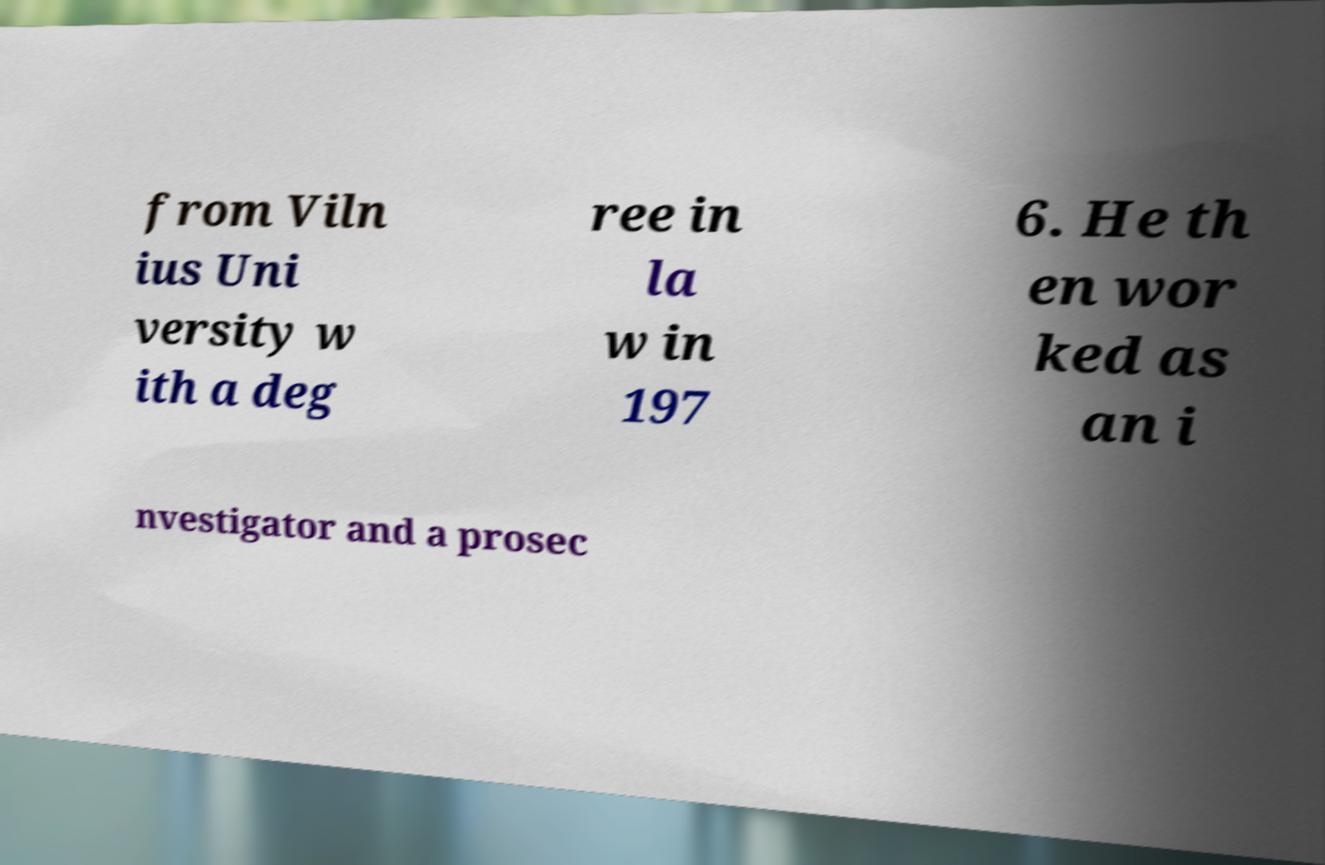Could you extract and type out the text from this image? from Viln ius Uni versity w ith a deg ree in la w in 197 6. He th en wor ked as an i nvestigator and a prosec 